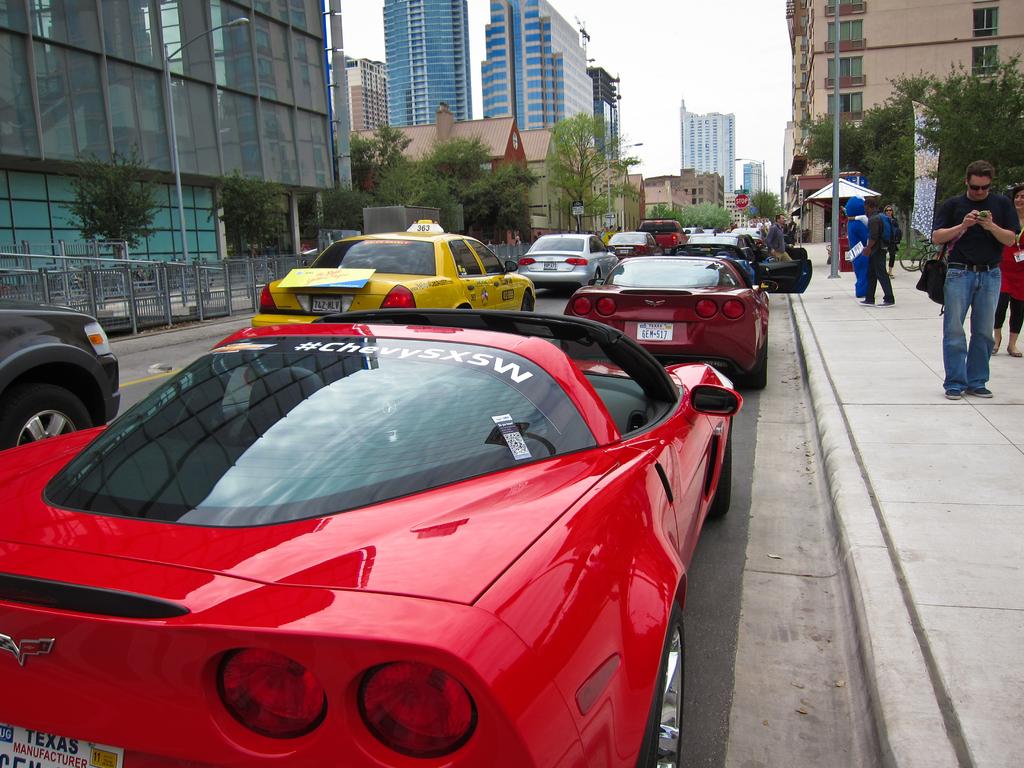What state is on the license plate?
Your answer should be very brief. Texas. What does the hashtag say?
Your response must be concise. Chevysxsw. 